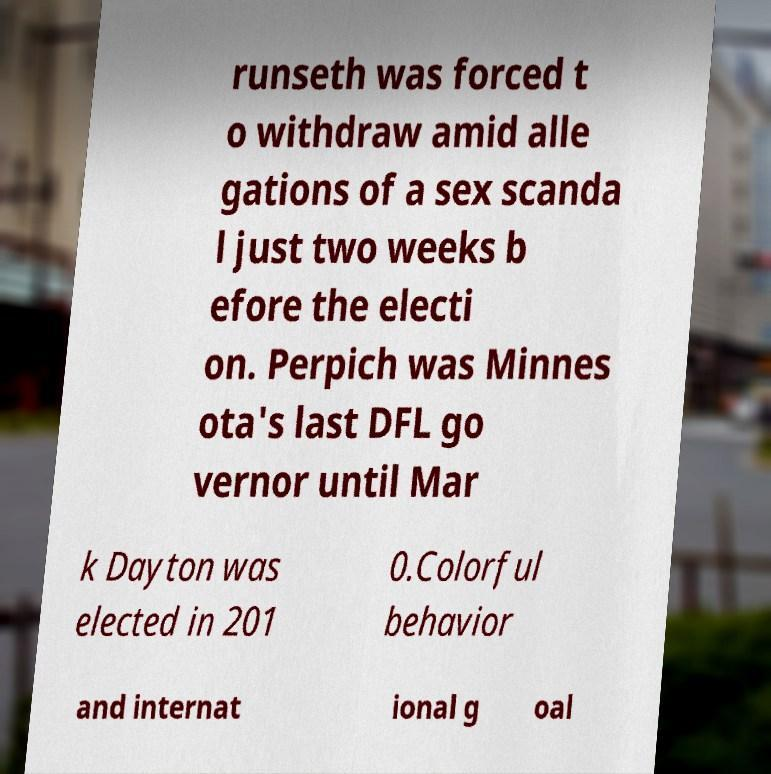What messages or text are displayed in this image? I need them in a readable, typed format. runseth was forced t o withdraw amid alle gations of a sex scanda l just two weeks b efore the electi on. Perpich was Minnes ota's last DFL go vernor until Mar k Dayton was elected in 201 0.Colorful behavior and internat ional g oal 